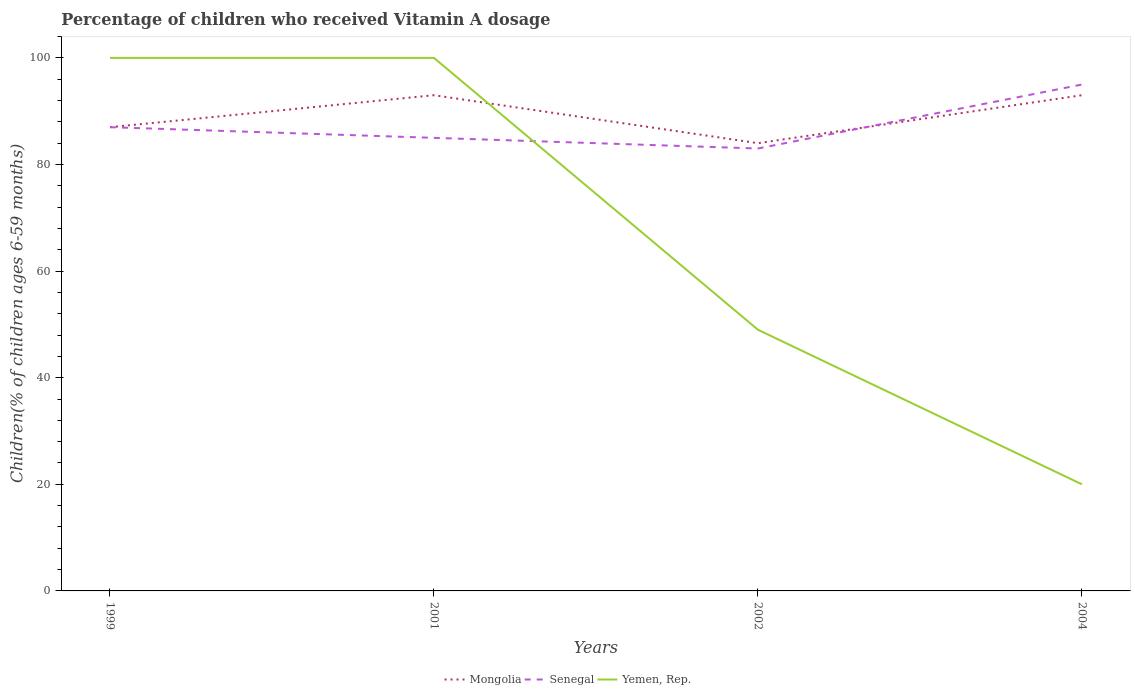In which year was the percentage of children who received Vitamin A dosage in Mongolia maximum?
Make the answer very short. 2002. What is the total percentage of children who received Vitamin A dosage in Senegal in the graph?
Offer a very short reply. 2. What is the difference between the highest and the second highest percentage of children who received Vitamin A dosage in Yemen, Rep.?
Keep it short and to the point. 80. How many lines are there?
Your answer should be very brief. 3. How many years are there in the graph?
Offer a very short reply. 4. What is the difference between two consecutive major ticks on the Y-axis?
Your answer should be compact. 20. Are the values on the major ticks of Y-axis written in scientific E-notation?
Provide a succinct answer. No. How are the legend labels stacked?
Your answer should be very brief. Horizontal. What is the title of the graph?
Your answer should be compact. Percentage of children who received Vitamin A dosage. What is the label or title of the Y-axis?
Offer a very short reply. Children(% of children ages 6-59 months). What is the Children(% of children ages 6-59 months) of Senegal in 1999?
Keep it short and to the point. 87. What is the Children(% of children ages 6-59 months) in Yemen, Rep. in 1999?
Your answer should be compact. 100. What is the Children(% of children ages 6-59 months) of Mongolia in 2001?
Give a very brief answer. 93. What is the Children(% of children ages 6-59 months) in Senegal in 2001?
Your answer should be compact. 85. What is the Children(% of children ages 6-59 months) of Yemen, Rep. in 2001?
Make the answer very short. 100. What is the Children(% of children ages 6-59 months) of Mongolia in 2002?
Your response must be concise. 84. What is the Children(% of children ages 6-59 months) in Senegal in 2002?
Make the answer very short. 83. What is the Children(% of children ages 6-59 months) in Yemen, Rep. in 2002?
Make the answer very short. 49. What is the Children(% of children ages 6-59 months) of Mongolia in 2004?
Your answer should be compact. 93. Across all years, what is the maximum Children(% of children ages 6-59 months) in Mongolia?
Ensure brevity in your answer.  93. Across all years, what is the minimum Children(% of children ages 6-59 months) in Mongolia?
Your answer should be very brief. 84. What is the total Children(% of children ages 6-59 months) in Mongolia in the graph?
Ensure brevity in your answer.  357. What is the total Children(% of children ages 6-59 months) of Senegal in the graph?
Your answer should be very brief. 350. What is the total Children(% of children ages 6-59 months) of Yemen, Rep. in the graph?
Your response must be concise. 269. What is the difference between the Children(% of children ages 6-59 months) in Mongolia in 1999 and that in 2001?
Give a very brief answer. -6. What is the difference between the Children(% of children ages 6-59 months) of Yemen, Rep. in 1999 and that in 2001?
Offer a very short reply. 0. What is the difference between the Children(% of children ages 6-59 months) of Yemen, Rep. in 1999 and that in 2002?
Offer a very short reply. 51. What is the difference between the Children(% of children ages 6-59 months) of Mongolia in 1999 and that in 2004?
Your answer should be very brief. -6. What is the difference between the Children(% of children ages 6-59 months) of Yemen, Rep. in 1999 and that in 2004?
Make the answer very short. 80. What is the difference between the Children(% of children ages 6-59 months) of Senegal in 2001 and that in 2002?
Ensure brevity in your answer.  2. What is the difference between the Children(% of children ages 6-59 months) in Yemen, Rep. in 2001 and that in 2002?
Your answer should be compact. 51. What is the difference between the Children(% of children ages 6-59 months) of Yemen, Rep. in 2001 and that in 2004?
Provide a succinct answer. 80. What is the difference between the Children(% of children ages 6-59 months) of Mongolia in 2002 and that in 2004?
Provide a succinct answer. -9. What is the difference between the Children(% of children ages 6-59 months) of Yemen, Rep. in 2002 and that in 2004?
Your answer should be compact. 29. What is the difference between the Children(% of children ages 6-59 months) in Mongolia in 1999 and the Children(% of children ages 6-59 months) in Yemen, Rep. in 2001?
Ensure brevity in your answer.  -13. What is the difference between the Children(% of children ages 6-59 months) of Senegal in 1999 and the Children(% of children ages 6-59 months) of Yemen, Rep. in 2001?
Your answer should be compact. -13. What is the difference between the Children(% of children ages 6-59 months) of Mongolia in 1999 and the Children(% of children ages 6-59 months) of Senegal in 2002?
Ensure brevity in your answer.  4. What is the difference between the Children(% of children ages 6-59 months) of Senegal in 1999 and the Children(% of children ages 6-59 months) of Yemen, Rep. in 2002?
Ensure brevity in your answer.  38. What is the difference between the Children(% of children ages 6-59 months) in Mongolia in 1999 and the Children(% of children ages 6-59 months) in Senegal in 2004?
Provide a succinct answer. -8. What is the difference between the Children(% of children ages 6-59 months) of Mongolia in 2001 and the Children(% of children ages 6-59 months) of Senegal in 2002?
Give a very brief answer. 10. What is the difference between the Children(% of children ages 6-59 months) in Senegal in 2001 and the Children(% of children ages 6-59 months) in Yemen, Rep. in 2002?
Your response must be concise. 36. What is the difference between the Children(% of children ages 6-59 months) in Mongolia in 2001 and the Children(% of children ages 6-59 months) in Senegal in 2004?
Your response must be concise. -2. What is the difference between the Children(% of children ages 6-59 months) in Mongolia in 2002 and the Children(% of children ages 6-59 months) in Senegal in 2004?
Ensure brevity in your answer.  -11. What is the difference between the Children(% of children ages 6-59 months) of Mongolia in 2002 and the Children(% of children ages 6-59 months) of Yemen, Rep. in 2004?
Ensure brevity in your answer.  64. What is the difference between the Children(% of children ages 6-59 months) of Senegal in 2002 and the Children(% of children ages 6-59 months) of Yemen, Rep. in 2004?
Ensure brevity in your answer.  63. What is the average Children(% of children ages 6-59 months) in Mongolia per year?
Ensure brevity in your answer.  89.25. What is the average Children(% of children ages 6-59 months) in Senegal per year?
Keep it short and to the point. 87.5. What is the average Children(% of children ages 6-59 months) of Yemen, Rep. per year?
Your answer should be compact. 67.25. In the year 1999, what is the difference between the Children(% of children ages 6-59 months) in Mongolia and Children(% of children ages 6-59 months) in Senegal?
Make the answer very short. 0. In the year 2001, what is the difference between the Children(% of children ages 6-59 months) of Senegal and Children(% of children ages 6-59 months) of Yemen, Rep.?
Give a very brief answer. -15. In the year 2002, what is the difference between the Children(% of children ages 6-59 months) in Mongolia and Children(% of children ages 6-59 months) in Yemen, Rep.?
Give a very brief answer. 35. In the year 2004, what is the difference between the Children(% of children ages 6-59 months) in Mongolia and Children(% of children ages 6-59 months) in Yemen, Rep.?
Give a very brief answer. 73. What is the ratio of the Children(% of children ages 6-59 months) of Mongolia in 1999 to that in 2001?
Your answer should be very brief. 0.94. What is the ratio of the Children(% of children ages 6-59 months) in Senegal in 1999 to that in 2001?
Keep it short and to the point. 1.02. What is the ratio of the Children(% of children ages 6-59 months) in Yemen, Rep. in 1999 to that in 2001?
Offer a terse response. 1. What is the ratio of the Children(% of children ages 6-59 months) in Mongolia in 1999 to that in 2002?
Provide a succinct answer. 1.04. What is the ratio of the Children(% of children ages 6-59 months) in Senegal in 1999 to that in 2002?
Offer a very short reply. 1.05. What is the ratio of the Children(% of children ages 6-59 months) in Yemen, Rep. in 1999 to that in 2002?
Your response must be concise. 2.04. What is the ratio of the Children(% of children ages 6-59 months) of Mongolia in 1999 to that in 2004?
Offer a terse response. 0.94. What is the ratio of the Children(% of children ages 6-59 months) of Senegal in 1999 to that in 2004?
Ensure brevity in your answer.  0.92. What is the ratio of the Children(% of children ages 6-59 months) of Mongolia in 2001 to that in 2002?
Offer a terse response. 1.11. What is the ratio of the Children(% of children ages 6-59 months) in Senegal in 2001 to that in 2002?
Ensure brevity in your answer.  1.02. What is the ratio of the Children(% of children ages 6-59 months) of Yemen, Rep. in 2001 to that in 2002?
Offer a terse response. 2.04. What is the ratio of the Children(% of children ages 6-59 months) in Senegal in 2001 to that in 2004?
Keep it short and to the point. 0.89. What is the ratio of the Children(% of children ages 6-59 months) in Yemen, Rep. in 2001 to that in 2004?
Give a very brief answer. 5. What is the ratio of the Children(% of children ages 6-59 months) in Mongolia in 2002 to that in 2004?
Your answer should be very brief. 0.9. What is the ratio of the Children(% of children ages 6-59 months) of Senegal in 2002 to that in 2004?
Ensure brevity in your answer.  0.87. What is the ratio of the Children(% of children ages 6-59 months) in Yemen, Rep. in 2002 to that in 2004?
Your answer should be very brief. 2.45. What is the difference between the highest and the lowest Children(% of children ages 6-59 months) of Senegal?
Ensure brevity in your answer.  12. 